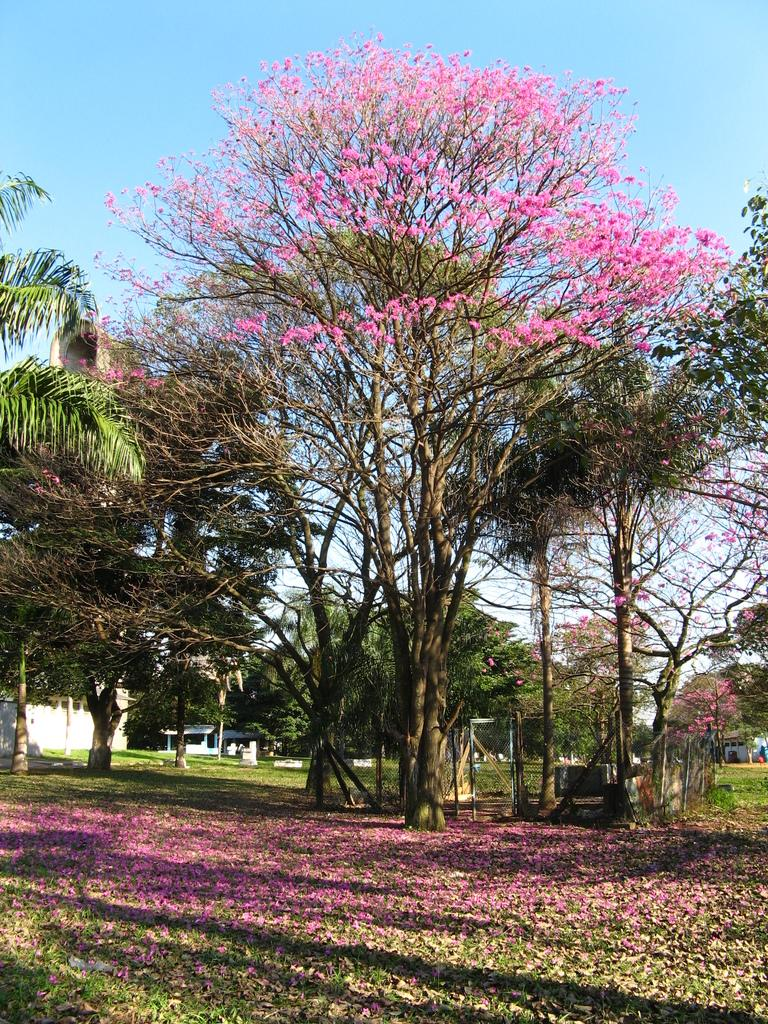What type of tree is present in the image? There is a tree with flowers in the image. What is the condition of the trees on the grassland? The trees on the grassland have flowers and dried leaves. What can be seen in the background of the image? There are buildings in the background of the image. What is visible at the top of the image? The sky is visible at the top of the image. What type of truck can be seen driving through the stem of the tree in the image? There is no truck present in the image, nor is there a stem of a tree visible. 